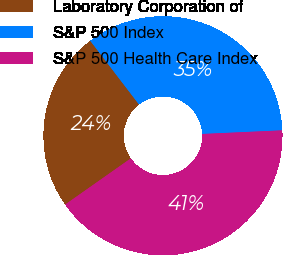<chart> <loc_0><loc_0><loc_500><loc_500><pie_chart><fcel>Laboratory Corporation of<fcel>S&P 500 Index<fcel>S&P 500 Health Care Index<nl><fcel>24.36%<fcel>34.67%<fcel>40.97%<nl></chart> 